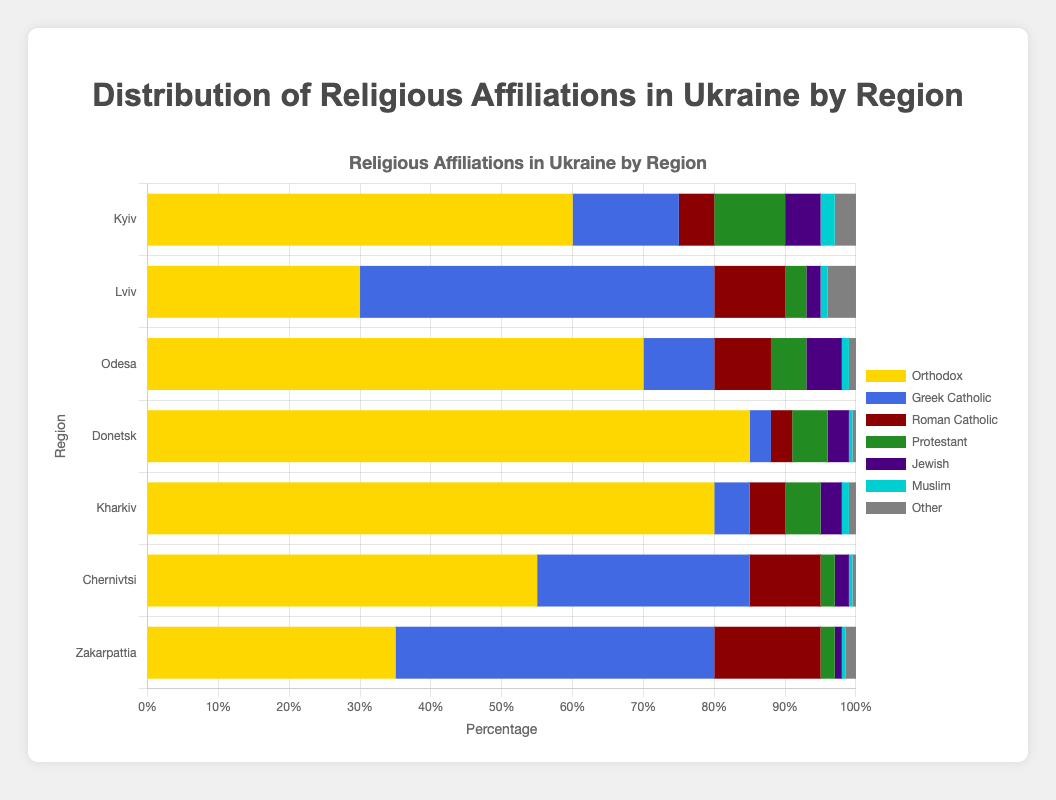What is the most common religious affiliation in Donetsk? The tallest bar in the Donetsk region represents the Orthodox affiliation. By referring to the percentage values, the Orthodox affiliation is 85%, the highest among all groups in Donetsk.
Answer: Orthodox Which region has the highest percentage of Greek Catholics? The region with the tallest bar for Greek Catholics is Lviv. The percentage value for Greek Catholics in Lviv is 50%, the highest compared to other regions.
Answer: Lviv What is the total percentage of non-Christian religious affiliations (Jewish, Muslim, Other) in Kyiv? In Kyiv, we sum the percentages of Jewish (5%), Muslim (2%), and Other (3%) to find the total percentage of non-Christian affiliations: 5 + 2 + 3 = 10%
Answer: 10% Compare the percentage of Roman Catholics in Kyiv and Odesa. Which region has a higher percentage? The height of the Roman Catholic bar in Odesa (8%) is taller than that in Kyiv (5%). Thus, Odesa has a higher percentage of Roman Catholics.
Answer: Odesa Which region has the lowest percentage of Muslims, and what is that percentage? By comparing the lengths of the Muslim bars in all regions, the shortest bar is in Donetsk with a percentage of 0.5%.
Answer: Donetsk, 0.5% In which region is the percentage of Protestants equal to the percentage of Jewish people? In Odesa, the height of the Protestant bar is equal to the height of the Jewish bar, both at 5%.
Answer: Odesa How does the proportion of Orthodox in Chernivtsi compare to that in Kharkiv? The Orthodox percentage in Chernivtsi is 55%, whereas in Kharkiv, it is 80%. Kharkiv has a higher proportion of Orthodox compared to Chernivtsi.
Answer: Kharkiv Calculate the average percentage of the Roman Catholic affiliation across all regions. Sum the Roman Catholic percentages in all regions: 5 (Kyiv) + 10 (Lviv) + 8 (Odesa) + 3 (Donetsk) + 5 (Kharkiv) + 10 (Chernivtsi) + 15 (Zakarpattia) = 56. Divide by the number of regions: 56 / 7 = 8%
Answer: 8% Which region has the closest percentage of Orthodox affiliation to Kyiv? Kyiv has an Orthodox affiliation of 60%. Comparing with other regions, Chernivtsi has 55%, which is the closest to Kyiv's 60%.
Answer: Chernivtsi What is the difference in the percentage of Greek Catholics between Lviv and Zakarpattia? Subtract the percentage of Greek Catholics in Zakarpattia (45%) from the percentage in Lviv (50%): 50 - 45 = 5%
Answer: 5% 